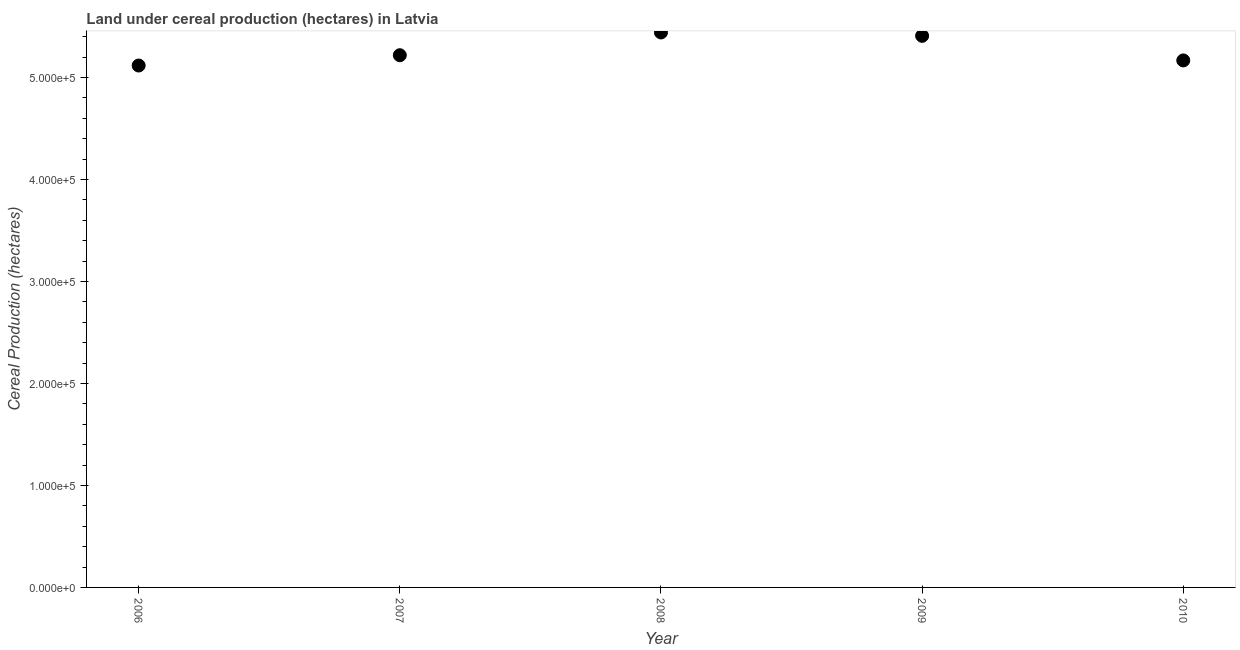What is the land under cereal production in 2008?
Your response must be concise. 5.44e+05. Across all years, what is the maximum land under cereal production?
Offer a terse response. 5.44e+05. Across all years, what is the minimum land under cereal production?
Make the answer very short. 5.12e+05. In which year was the land under cereal production maximum?
Offer a very short reply. 2008. In which year was the land under cereal production minimum?
Give a very brief answer. 2006. What is the sum of the land under cereal production?
Offer a very short reply. 2.64e+06. What is the difference between the land under cereal production in 2006 and 2009?
Your answer should be very brief. -2.91e+04. What is the average land under cereal production per year?
Make the answer very short. 5.27e+05. What is the median land under cereal production?
Keep it short and to the point. 5.22e+05. Do a majority of the years between 2006 and 2007 (inclusive) have land under cereal production greater than 80000 hectares?
Offer a terse response. Yes. What is the ratio of the land under cereal production in 2006 to that in 2007?
Provide a short and direct response. 0.98. Is the land under cereal production in 2009 less than that in 2010?
Offer a terse response. No. Is the difference between the land under cereal production in 2006 and 2007 greater than the difference between any two years?
Keep it short and to the point. No. What is the difference between the highest and the second highest land under cereal production?
Provide a succinct answer. 3300. Is the sum of the land under cereal production in 2007 and 2008 greater than the maximum land under cereal production across all years?
Your answer should be compact. Yes. What is the difference between the highest and the lowest land under cereal production?
Give a very brief answer. 3.24e+04. How many dotlines are there?
Keep it short and to the point. 1. How many years are there in the graph?
Make the answer very short. 5. Does the graph contain grids?
Your answer should be very brief. No. What is the title of the graph?
Your answer should be very brief. Land under cereal production (hectares) in Latvia. What is the label or title of the Y-axis?
Your answer should be very brief. Cereal Production (hectares). What is the Cereal Production (hectares) in 2006?
Your answer should be compact. 5.12e+05. What is the Cereal Production (hectares) in 2007?
Offer a very short reply. 5.22e+05. What is the Cereal Production (hectares) in 2008?
Your answer should be compact. 5.44e+05. What is the Cereal Production (hectares) in 2009?
Ensure brevity in your answer.  5.41e+05. What is the Cereal Production (hectares) in 2010?
Offer a terse response. 5.17e+05. What is the difference between the Cereal Production (hectares) in 2006 and 2007?
Your answer should be very brief. -1.01e+04. What is the difference between the Cereal Production (hectares) in 2006 and 2008?
Ensure brevity in your answer.  -3.24e+04. What is the difference between the Cereal Production (hectares) in 2006 and 2009?
Offer a terse response. -2.91e+04. What is the difference between the Cereal Production (hectares) in 2006 and 2010?
Your response must be concise. -5000. What is the difference between the Cereal Production (hectares) in 2007 and 2008?
Offer a very short reply. -2.23e+04. What is the difference between the Cereal Production (hectares) in 2007 and 2009?
Ensure brevity in your answer.  -1.90e+04. What is the difference between the Cereal Production (hectares) in 2007 and 2010?
Offer a terse response. 5100. What is the difference between the Cereal Production (hectares) in 2008 and 2009?
Keep it short and to the point. 3300. What is the difference between the Cereal Production (hectares) in 2008 and 2010?
Offer a very short reply. 2.74e+04. What is the difference between the Cereal Production (hectares) in 2009 and 2010?
Ensure brevity in your answer.  2.41e+04. What is the ratio of the Cereal Production (hectares) in 2006 to that in 2009?
Provide a succinct answer. 0.95. What is the ratio of the Cereal Production (hectares) in 2007 to that in 2009?
Your response must be concise. 0.96. What is the ratio of the Cereal Production (hectares) in 2008 to that in 2010?
Provide a succinct answer. 1.05. What is the ratio of the Cereal Production (hectares) in 2009 to that in 2010?
Give a very brief answer. 1.05. 